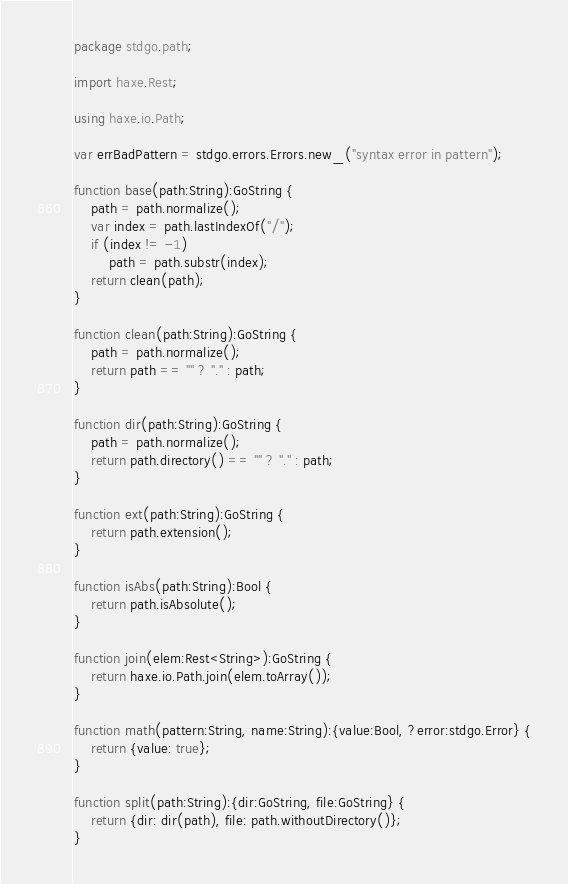Convert code to text. <code><loc_0><loc_0><loc_500><loc_500><_Haxe_>package stdgo.path;

import haxe.Rest;

using haxe.io.Path;

var errBadPattern = stdgo.errors.Errors.new_("syntax error in pattern");

function base(path:String):GoString {
	path = path.normalize();
	var index = path.lastIndexOf("/");
	if (index != -1)
		path = path.substr(index);
	return clean(path);
}

function clean(path:String):GoString {
	path = path.normalize();
	return path == "" ? "." : path;
}

function dir(path:String):GoString {
	path = path.normalize();
	return path.directory() == "" ? "." : path;
}

function ext(path:String):GoString {
	return path.extension();
}

function isAbs(path:String):Bool {
	return path.isAbsolute();
}

function join(elem:Rest<String>):GoString {
	return haxe.io.Path.join(elem.toArray());
}

function math(pattern:String, name:String):{value:Bool, ?error:stdgo.Error} {
	return {value: true};
}

function split(path:String):{dir:GoString, file:GoString} {
	return {dir: dir(path), file: path.withoutDirectory()};
}
</code> 